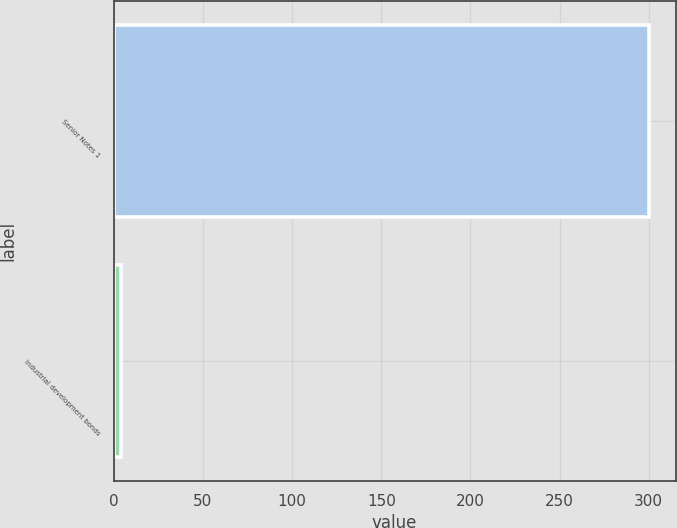<chart> <loc_0><loc_0><loc_500><loc_500><bar_chart><fcel>Senior Notes 1<fcel>Industrial development bonds<nl><fcel>300<fcel>3.8<nl></chart> 